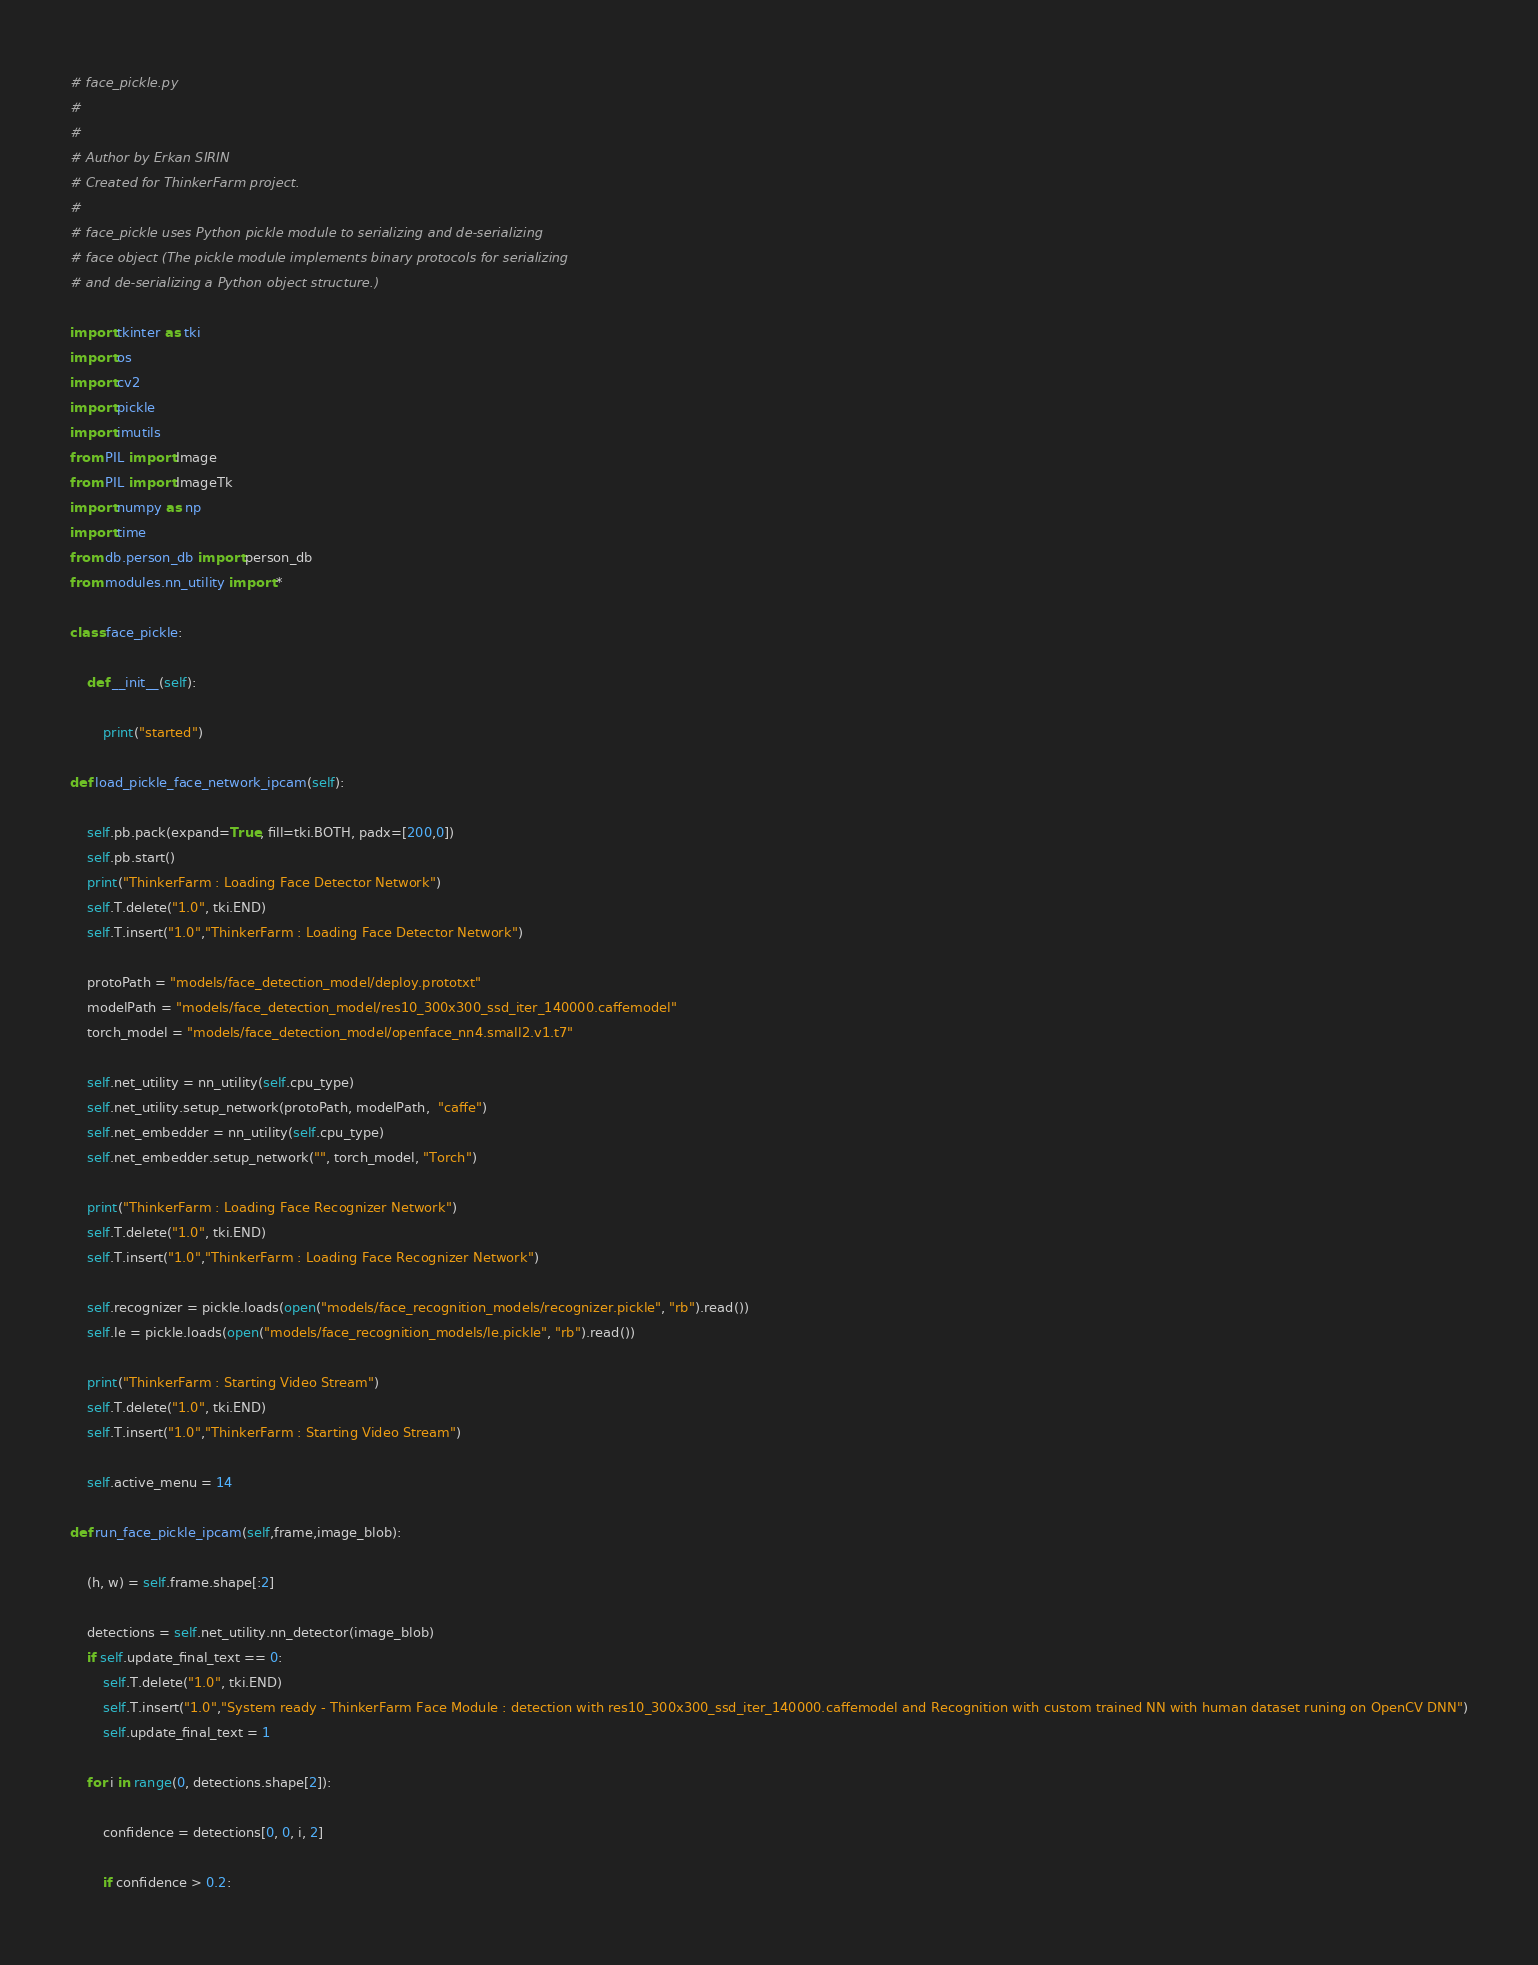Convert code to text. <code><loc_0><loc_0><loc_500><loc_500><_Python_># face_pickle.py
#
#
# Author by Erkan SIRIN
# Created for ThinkerFarm project.
#
# face_pickle uses Python pickle module to serializing and de-serializing
# face object (The pickle module implements binary protocols for serializing
# and de-serializing a Python object structure.)

import tkinter as tki
import os
import cv2
import pickle
import imutils
from PIL import Image
from PIL import ImageTk
import numpy as np
import time
from db.person_db import person_db
from modules.nn_utility import *

class face_pickle:

    def __init__(self):

        print("started")

def load_pickle_face_network_ipcam(self):

    self.pb.pack(expand=True, fill=tki.BOTH, padx=[200,0])
    self.pb.start()
    print("ThinkerFarm : Loading Face Detector Network")
    self.T.delete("1.0", tki.END)
    self.T.insert("1.0","ThinkerFarm : Loading Face Detector Network")

    protoPath = "models/face_detection_model/deploy.prototxt"
    modelPath = "models/face_detection_model/res10_300x300_ssd_iter_140000.caffemodel"
    torch_model = "models/face_detection_model/openface_nn4.small2.v1.t7"

    self.net_utility = nn_utility(self.cpu_type)
    self.net_utility.setup_network(protoPath, modelPath,  "caffe")
    self.net_embedder = nn_utility(self.cpu_type)
    self.net_embedder.setup_network("", torch_model, "Torch")

    print("ThinkerFarm : Loading Face Recognizer Network")
    self.T.delete("1.0", tki.END)
    self.T.insert("1.0","ThinkerFarm : Loading Face Recognizer Network")

    self.recognizer = pickle.loads(open("models/face_recognition_models/recognizer.pickle", "rb").read())
    self.le = pickle.loads(open("models/face_recognition_models/le.pickle", "rb").read())

    print("ThinkerFarm : Starting Video Stream")
    self.T.delete("1.0", tki.END)
    self.T.insert("1.0","ThinkerFarm : Starting Video Stream")

    self.active_menu = 14

def run_face_pickle_ipcam(self,frame,image_blob):

    (h, w) = self.frame.shape[:2]

    detections = self.net_utility.nn_detector(image_blob)
    if self.update_final_text == 0:
        self.T.delete("1.0", tki.END)
        self.T.insert("1.0","System ready - ThinkerFarm Face Module : detection with res10_300x300_ssd_iter_140000.caffemodel and Recognition with custom trained NN with human dataset runing on OpenCV DNN")
        self.update_final_text = 1

    for i in range(0, detections.shape[2]):

        confidence = detections[0, 0, i, 2]

        if confidence > 0.2:
</code> 